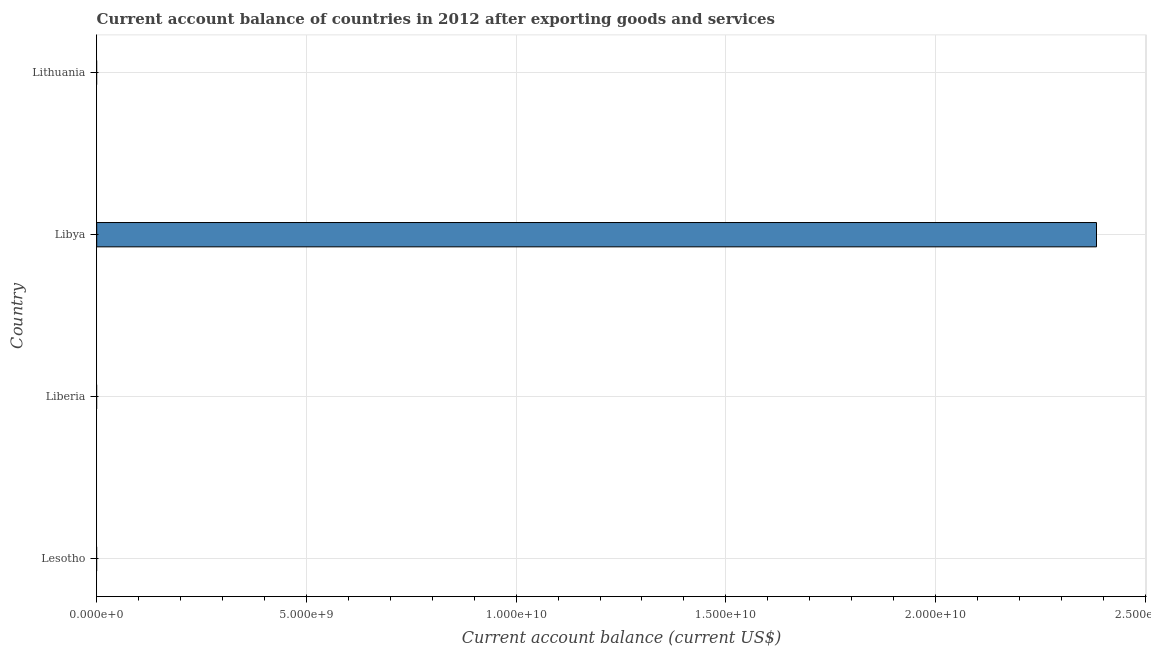What is the title of the graph?
Provide a short and direct response. Current account balance of countries in 2012 after exporting goods and services. What is the label or title of the X-axis?
Your answer should be very brief. Current account balance (current US$). What is the label or title of the Y-axis?
Your answer should be compact. Country. What is the current account balance in Libya?
Keep it short and to the point. 2.38e+1. Across all countries, what is the maximum current account balance?
Provide a short and direct response. 2.38e+1. In which country was the current account balance maximum?
Keep it short and to the point. Libya. What is the sum of the current account balance?
Give a very brief answer. 2.38e+1. What is the average current account balance per country?
Offer a very short reply. 5.96e+09. What is the difference between the highest and the lowest current account balance?
Your answer should be compact. 2.38e+1. In how many countries, is the current account balance greater than the average current account balance taken over all countries?
Your answer should be very brief. 1. How many bars are there?
Your response must be concise. 1. Are all the bars in the graph horizontal?
Your answer should be compact. Yes. How many countries are there in the graph?
Offer a very short reply. 4. What is the difference between two consecutive major ticks on the X-axis?
Keep it short and to the point. 5.00e+09. What is the Current account balance (current US$) of Lesotho?
Ensure brevity in your answer.  0. What is the Current account balance (current US$) in Libya?
Your response must be concise. 2.38e+1. 